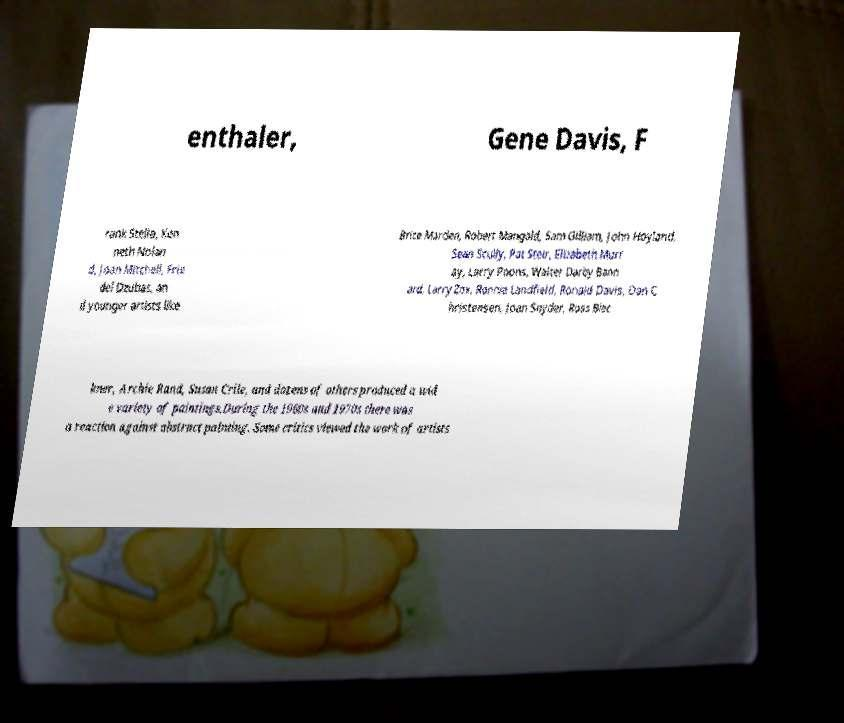Please read and relay the text visible in this image. What does it say? enthaler, Gene Davis, F rank Stella, Ken neth Nolan d, Joan Mitchell, Frie del Dzubas, an d younger artists like Brice Marden, Robert Mangold, Sam Gilliam, John Hoyland, Sean Scully, Pat Steir, Elizabeth Murr ay, Larry Poons, Walter Darby Bann ard, Larry Zox, Ronnie Landfield, Ronald Davis, Dan C hristensen, Joan Snyder, Ross Blec kner, Archie Rand, Susan Crile, and dozens of others produced a wid e variety of paintings.During the 1960s and 1970s there was a reaction against abstract painting. Some critics viewed the work of artists 